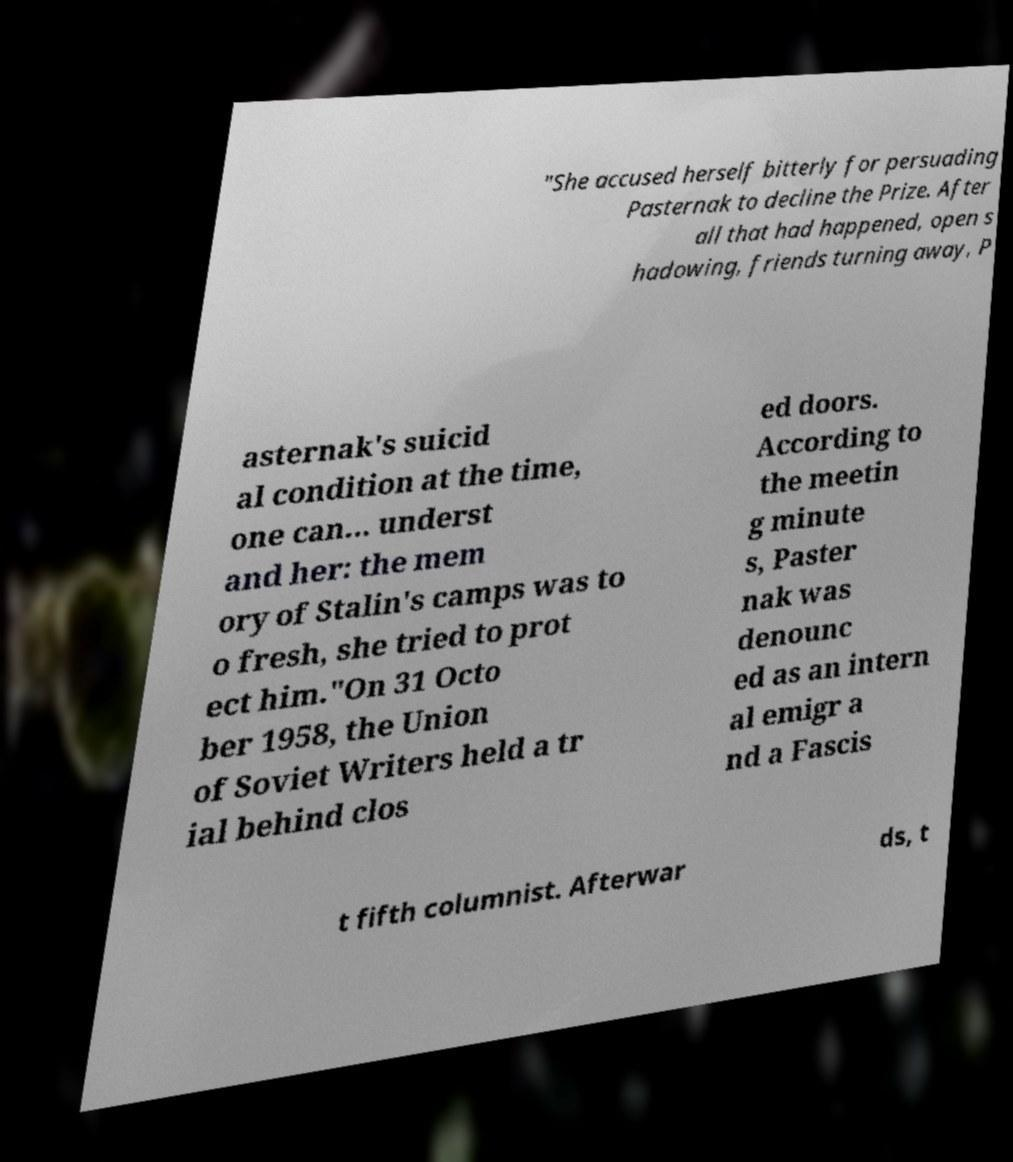Can you read and provide the text displayed in the image?This photo seems to have some interesting text. Can you extract and type it out for me? "She accused herself bitterly for persuading Pasternak to decline the Prize. After all that had happened, open s hadowing, friends turning away, P asternak's suicid al condition at the time, one can... underst and her: the mem ory of Stalin's camps was to o fresh, she tried to prot ect him."On 31 Octo ber 1958, the Union of Soviet Writers held a tr ial behind clos ed doors. According to the meetin g minute s, Paster nak was denounc ed as an intern al emigr a nd a Fascis t fifth columnist. Afterwar ds, t 